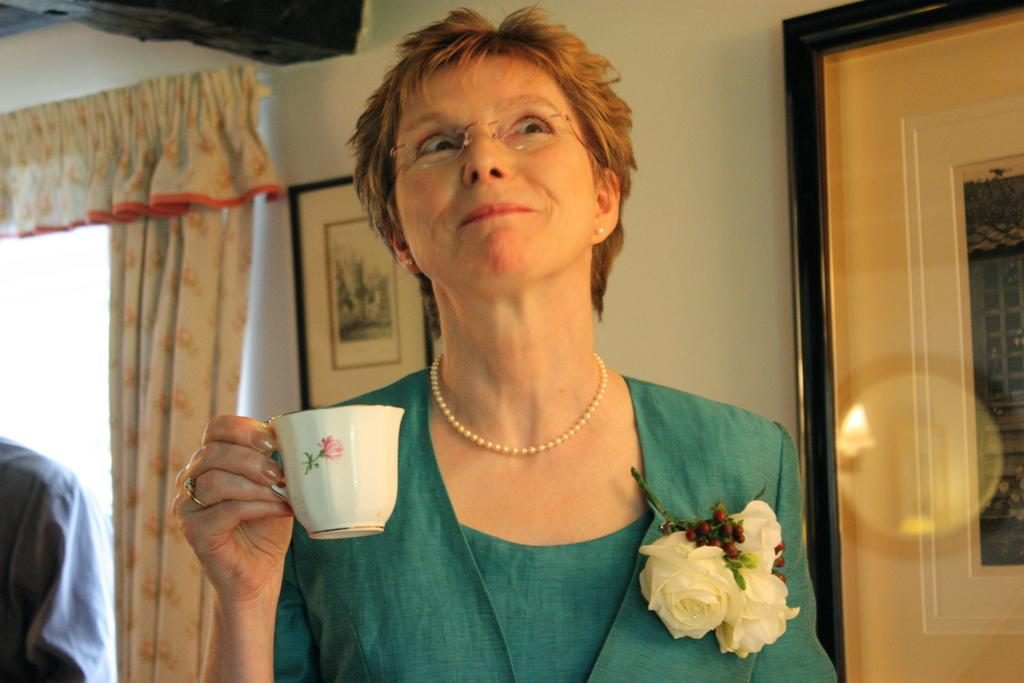What is the person in the image holding? There is a person holding a cup in the image. What can be seen in the background of the image? There is a curtain, a wall, and a frame in the background of the image. What type of yam is the person eating in the image? There is no yam present in the image; the person is holding a cup. What type of cap is the person wearing in the image? There is no cap present in the image; the person is holding a cup. Can you see a basketball in the image? There is no basketball present in the image. 